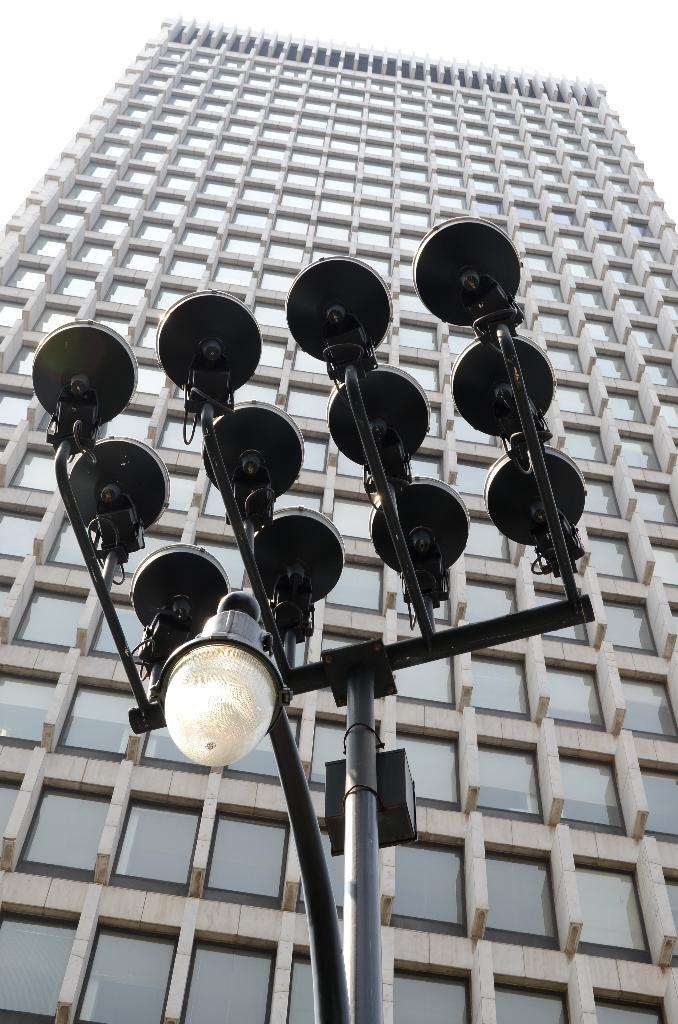What type of structure is visible in the picture? There is a building in the picture. What kind of lighting is present in the picture? There is a pole light in the light in the picture. What is the condition of the sky in the picture? The sky is cloudy in the picture. How many pets are visible in the picture? There are no pets present in the image. What example can be seen in the picture? There is no specific example being demonstrated in the image. 